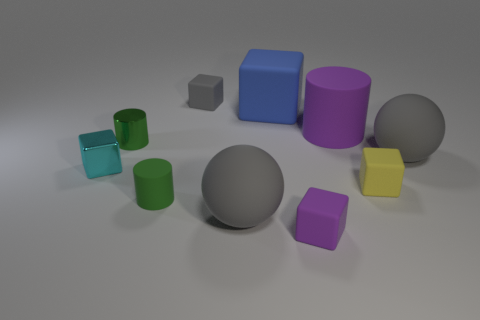There is a big cylinder; does it have the same color as the small matte cube that is in front of the small yellow rubber thing?
Keep it short and to the point. Yes. The tiny object that is both behind the cyan object and to the right of the tiny matte cylinder has what shape?
Offer a terse response. Cube. There is a small cyan object left of the rubber cylinder that is right of the green object in front of the small cyan metal thing; what is it made of?
Give a very brief answer. Metal. Are there more tiny green rubber objects that are behind the tiny yellow rubber object than yellow rubber cubes that are behind the cyan metallic object?
Provide a short and direct response. No. How many tiny red cylinders are made of the same material as the small purple thing?
Provide a short and direct response. 0. There is a gray object behind the large blue cube; is it the same shape as the purple rubber thing behind the small green matte cylinder?
Provide a succinct answer. No. What is the color of the rubber sphere that is on the right side of the large cylinder?
Provide a short and direct response. Gray. Are there any cyan shiny things that have the same shape as the tiny gray object?
Offer a very short reply. Yes. What is the material of the cyan cube?
Make the answer very short. Metal. There is a gray thing that is both on the right side of the tiny gray block and behind the small cyan object; how big is it?
Give a very brief answer. Large. 